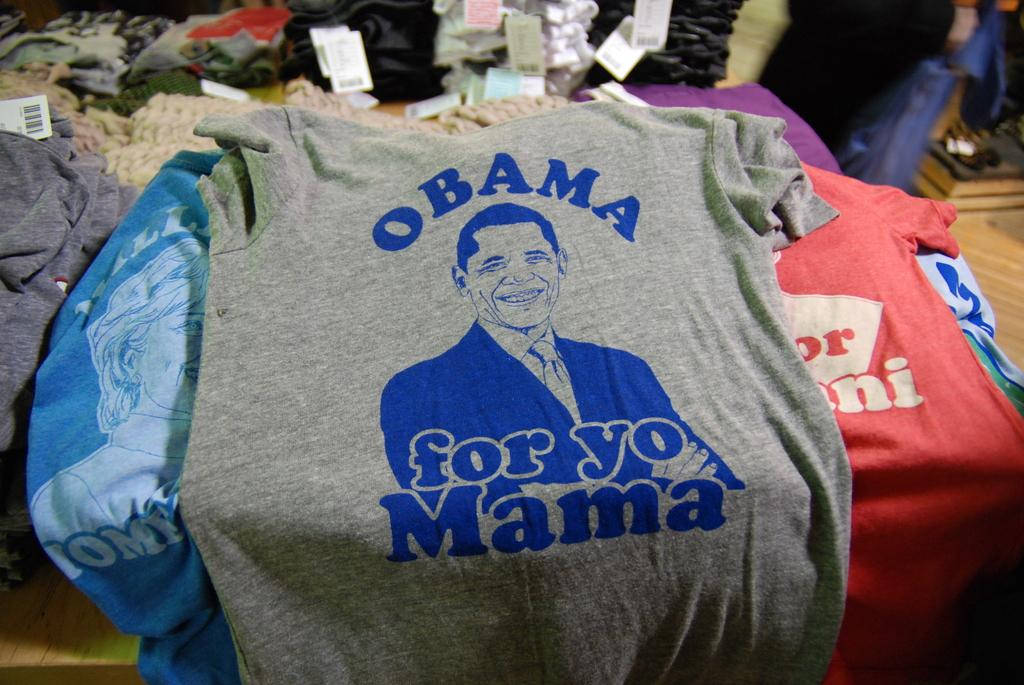<image>
Present a compact description of the photo's key features. T-shirts on a table with the words Obama for yo Mama with picture. 